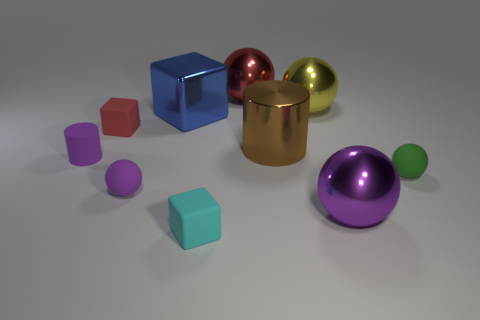Subtract all red metal spheres. How many spheres are left? 4 Subtract all cyan blocks. How many purple balls are left? 2 Subtract all green spheres. How many spheres are left? 4 Subtract all green spheres. Subtract all red cylinders. How many spheres are left? 4 Subtract all blocks. How many objects are left? 7 Subtract 1 purple balls. How many objects are left? 9 Subtract all purple cubes. Subtract all matte blocks. How many objects are left? 8 Add 1 small purple objects. How many small purple objects are left? 3 Add 3 yellow objects. How many yellow objects exist? 4 